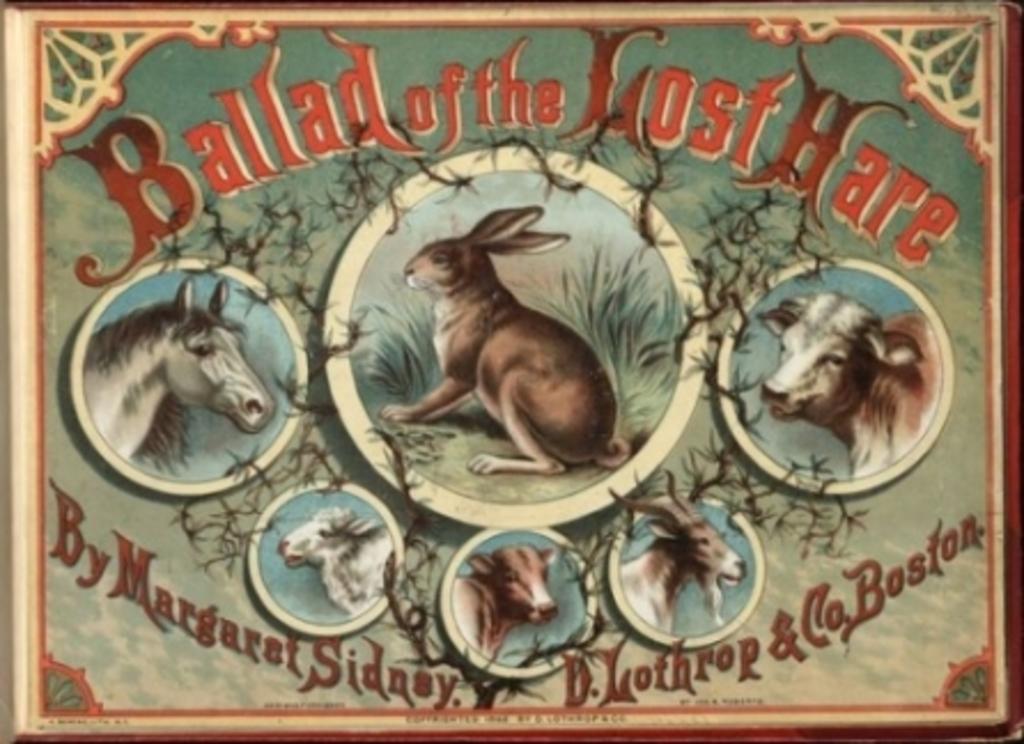In one or two sentences, can you explain what this image depicts? In this image we can see the frame and on the frame we can see the depiction of some animals and also grass. We can also see the text. 